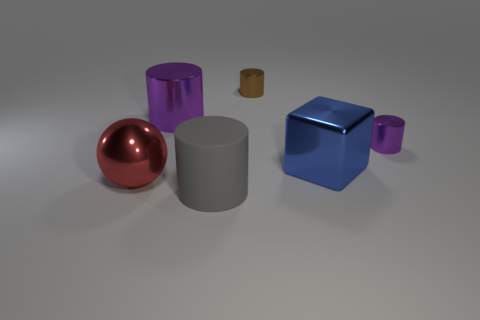Is the number of metal things on the left side of the large gray matte object less than the number of brown metallic objects that are in front of the big red metallic sphere?
Your answer should be very brief. No. What number of other objects are there of the same material as the red thing?
Provide a succinct answer. 4. There is a tiny thing behind the small purple shiny cylinder; is it the same color as the sphere?
Provide a succinct answer. No. Is there a big purple cylinder that is right of the big cylinder behind the big red ball?
Provide a succinct answer. No. What material is the object that is right of the small brown metallic cylinder and behind the big blue metal thing?
Give a very brief answer. Metal. There is a big blue object that is made of the same material as the big red object; what shape is it?
Offer a terse response. Cube. Is there anything else that has the same shape as the gray object?
Give a very brief answer. Yes. Are the large thing to the right of the matte cylinder and the large purple object made of the same material?
Ensure brevity in your answer.  Yes. There is a big gray object in front of the brown metal cylinder; what is it made of?
Your answer should be compact. Rubber. There is a purple shiny object on the right side of the cylinder that is in front of the large red thing; how big is it?
Make the answer very short. Small. 